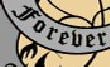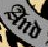Transcribe the words shown in these images in order, separated by a semicolon. Forever; And 